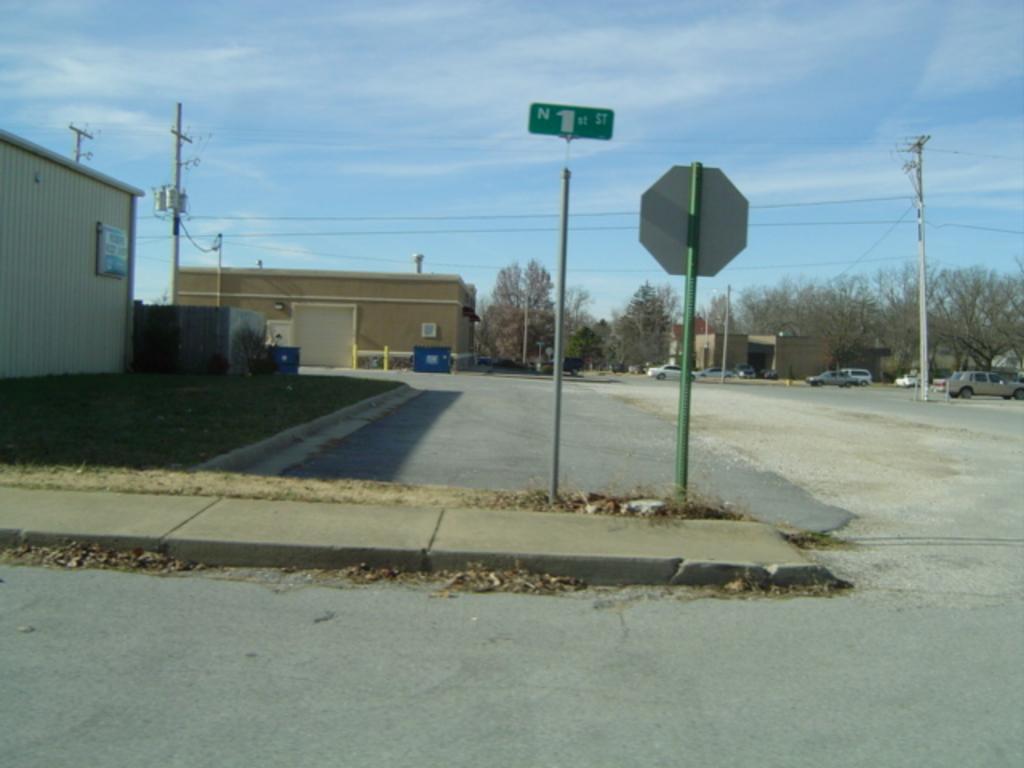Could you give a brief overview of what you see in this image? There are vehicles on the road. Here we can see poles, boards, grass, trees, and houses. In the background there is sky. 